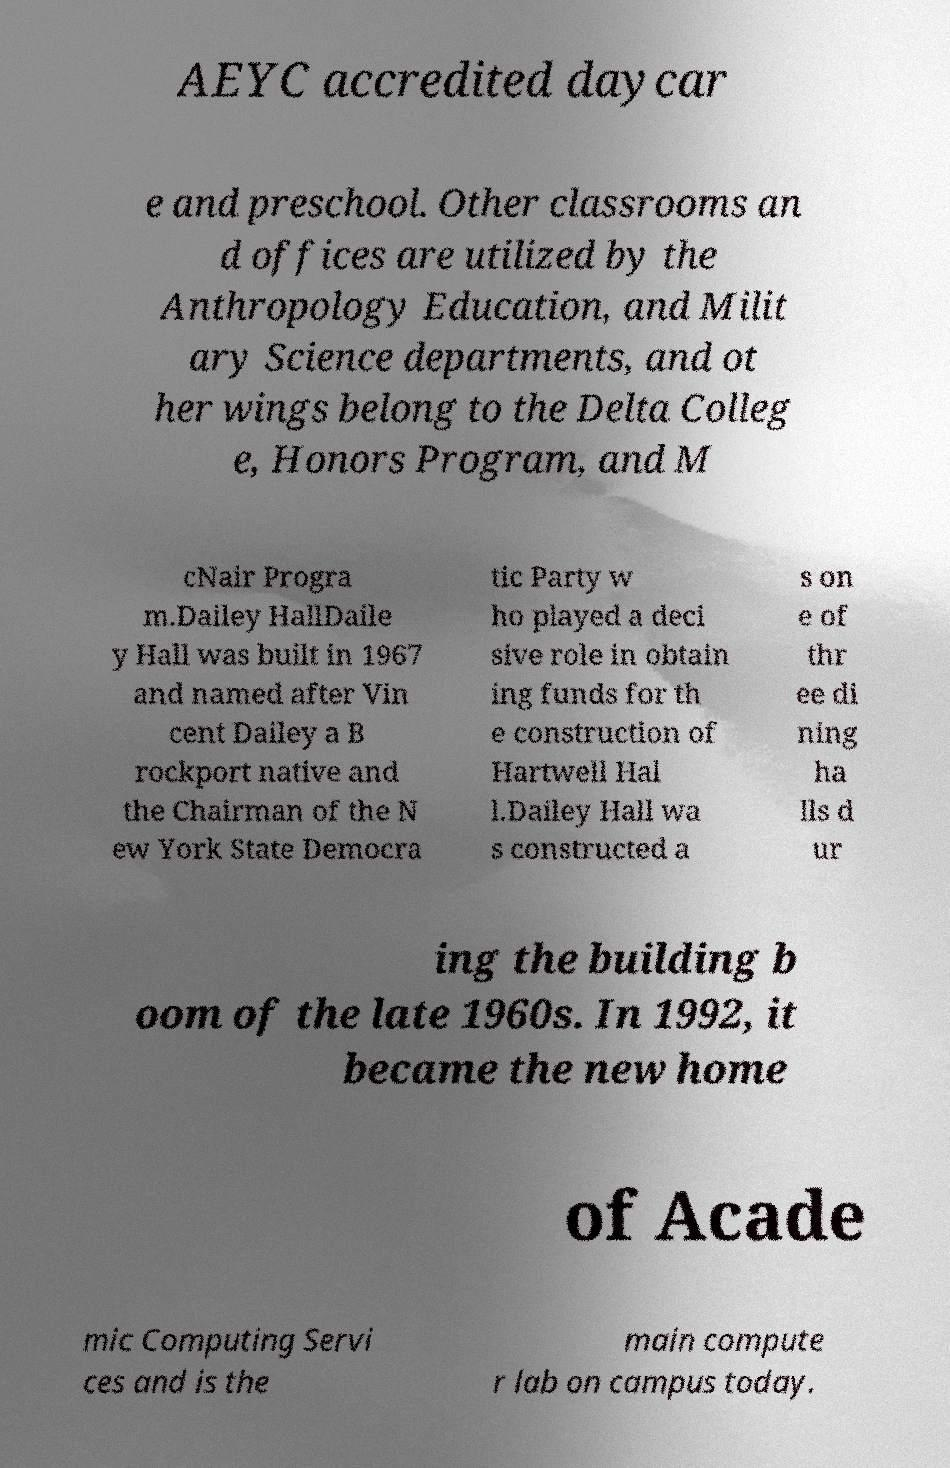Could you assist in decoding the text presented in this image and type it out clearly? AEYC accredited daycar e and preschool. Other classrooms an d offices are utilized by the Anthropology Education, and Milit ary Science departments, and ot her wings belong to the Delta Colleg e, Honors Program, and M cNair Progra m.Dailey HallDaile y Hall was built in 1967 and named after Vin cent Dailey a B rockport native and the Chairman of the N ew York State Democra tic Party w ho played a deci sive role in obtain ing funds for th e construction of Hartwell Hal l.Dailey Hall wa s constructed a s on e of thr ee di ning ha lls d ur ing the building b oom of the late 1960s. In 1992, it became the new home of Acade mic Computing Servi ces and is the main compute r lab on campus today. 